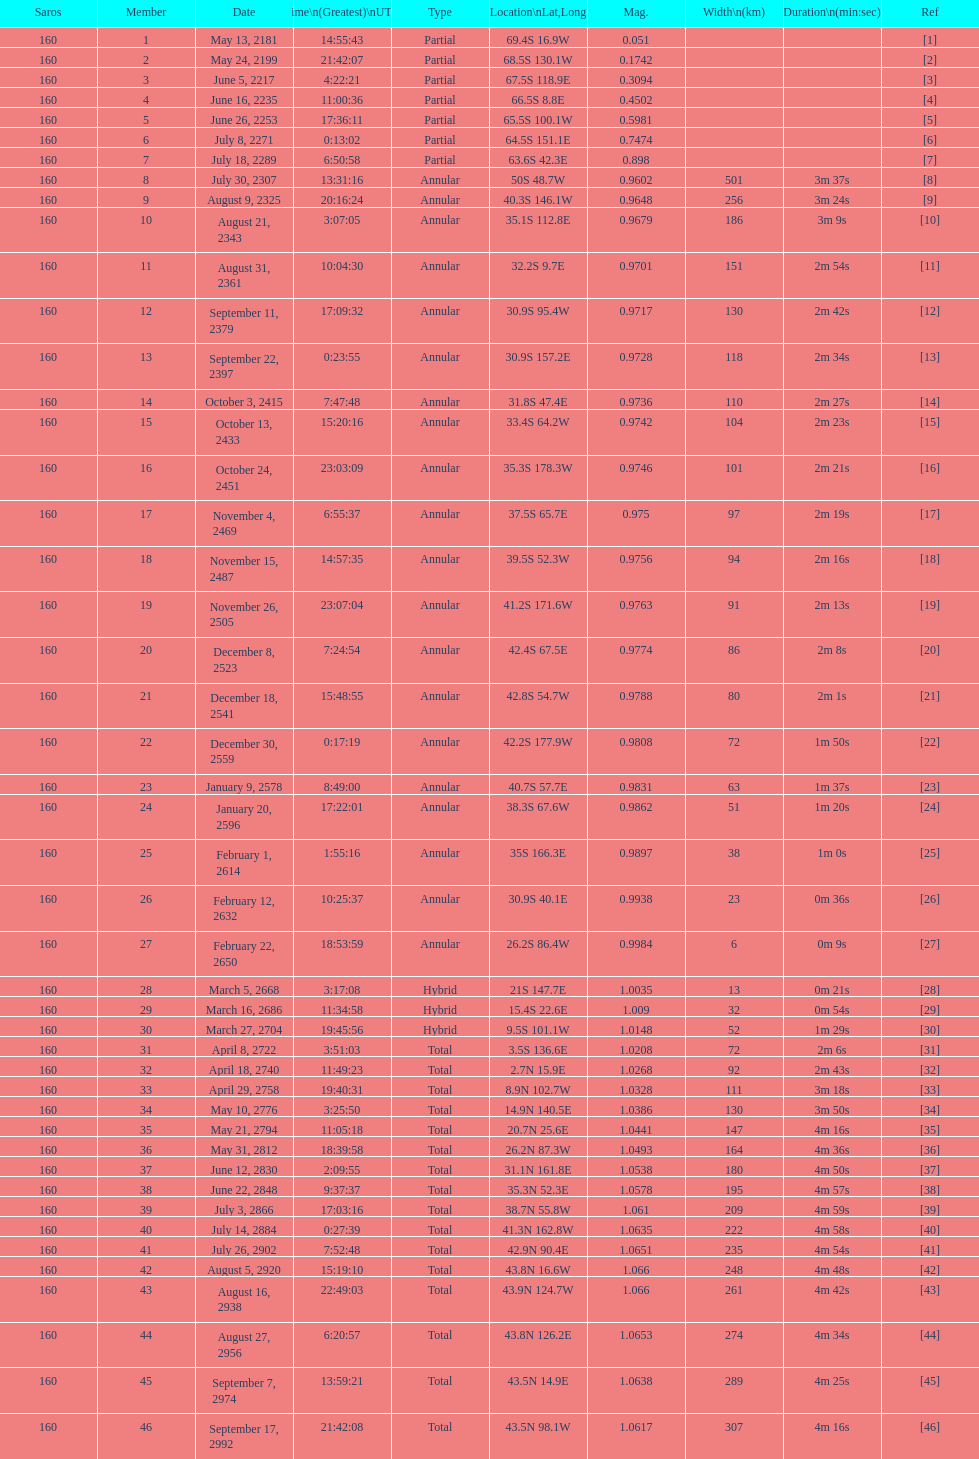Name a member number with a latitude above 60 s. 1. 